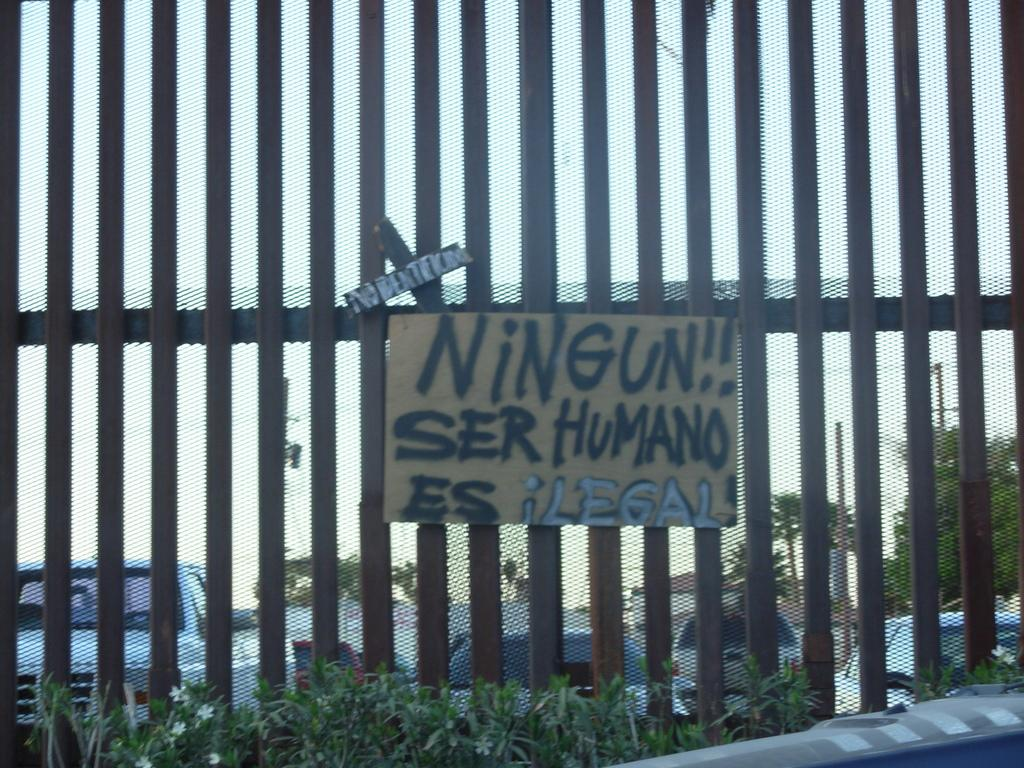What type of objects can be seen in the image? There are metal rods, a name board, and a fence in the image. What can be found in the background of the image? In the background of the image, there are cars, houses, poles, and trees. Can you describe the fence in the image? The fence is made of metal rods. How many apples are hanging from the metal rods in the image? There are no apples present in the image; it only features metal rods, a name board, and a fence. What color are the eyes of the person in the image? There is no person present in the image, so it is not possible to determine the color of their eyes. 